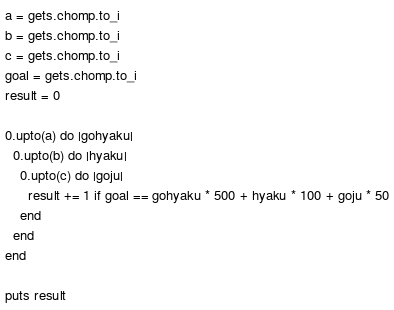<code> <loc_0><loc_0><loc_500><loc_500><_Ruby_>a = gets.chomp.to_i
b = gets.chomp.to_i
c = gets.chomp.to_i
goal = gets.chomp.to_i
result = 0

0.upto(a) do |gohyaku|
  0.upto(b) do |hyaku|
    0.upto(c) do |goju|
      result += 1 if goal == gohyaku * 500 + hyaku * 100 + goju * 50
    end
  end
end

puts result
</code> 